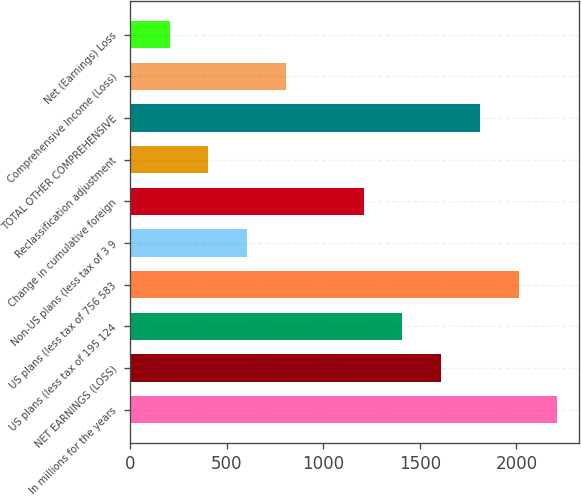Convert chart. <chart><loc_0><loc_0><loc_500><loc_500><bar_chart><fcel>In millions for the years<fcel>NET EARNINGS (LOSS)<fcel>US plans (less tax of 195 124<fcel>US plans (less tax of 756 583<fcel>Non-US plans (less tax of 3 9<fcel>Change in cumulative foreign<fcel>Reclassification adjustment<fcel>TOTAL OTHER COMPREHENSIVE<fcel>Comprehensive Income (Loss)<fcel>Net (Earnings) Loss<nl><fcel>2212.9<fcel>1610.2<fcel>1409.3<fcel>2012<fcel>605.7<fcel>1208.4<fcel>404.8<fcel>1811.1<fcel>806.6<fcel>203.9<nl></chart> 